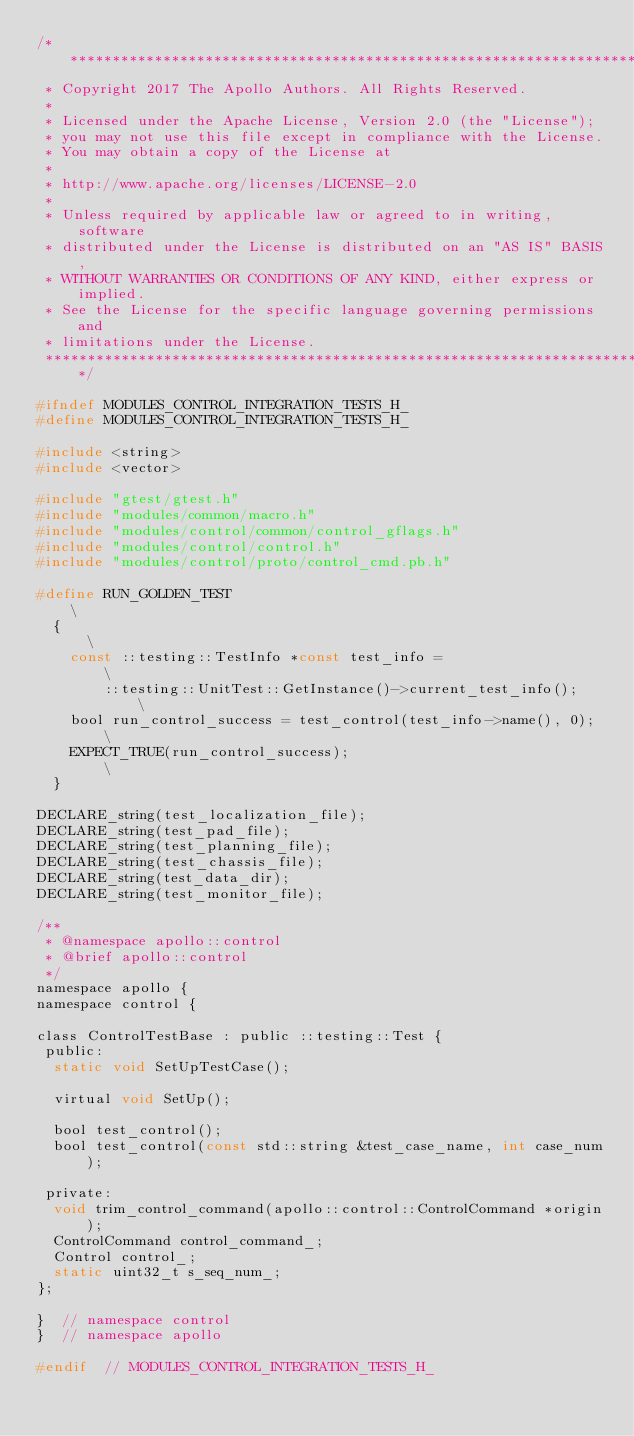Convert code to text. <code><loc_0><loc_0><loc_500><loc_500><_C_>/******************************************************************************
 * Copyright 2017 The Apollo Authors. All Rights Reserved.
 *
 * Licensed under the Apache License, Version 2.0 (the "License");
 * you may not use this file except in compliance with the License.
 * You may obtain a copy of the License at
 *
 * http://www.apache.org/licenses/LICENSE-2.0
 *
 * Unless required by applicable law or agreed to in writing, software
 * distributed under the License is distributed on an "AS IS" BASIS,
 * WITHOUT WARRANTIES OR CONDITIONS OF ANY KIND, either express or implied.
 * See the License for the specific language governing permissions and
 * limitations under the License.
 *****************************************************************************/

#ifndef MODULES_CONTROL_INTEGRATION_TESTS_H_
#define MODULES_CONTROL_INTEGRATION_TESTS_H_

#include <string>
#include <vector>

#include "gtest/gtest.h"
#include "modules/common/macro.h"
#include "modules/control/common/control_gflags.h"
#include "modules/control/control.h"
#include "modules/control/proto/control_cmd.pb.h"

#define RUN_GOLDEN_TEST                                            \
  {                                                                \
    const ::testing::TestInfo *const test_info =                   \
        ::testing::UnitTest::GetInstance()->current_test_info();   \
    bool run_control_success = test_control(test_info->name(), 0); \
    EXPECT_TRUE(run_control_success);                              \
  }

DECLARE_string(test_localization_file);
DECLARE_string(test_pad_file);
DECLARE_string(test_planning_file);
DECLARE_string(test_chassis_file);
DECLARE_string(test_data_dir);
DECLARE_string(test_monitor_file);

/**
 * @namespace apollo::control
 * @brief apollo::control
 */
namespace apollo {
namespace control {

class ControlTestBase : public ::testing::Test {
 public:
  static void SetUpTestCase();

  virtual void SetUp();

  bool test_control();
  bool test_control(const std::string &test_case_name, int case_num);

 private:
  void trim_control_command(apollo::control::ControlCommand *origin);
  ControlCommand control_command_;
  Control control_;
  static uint32_t s_seq_num_;
};

}  // namespace control
}  // namespace apollo

#endif  // MODULES_CONTROL_INTEGRATION_TESTS_H_
</code> 